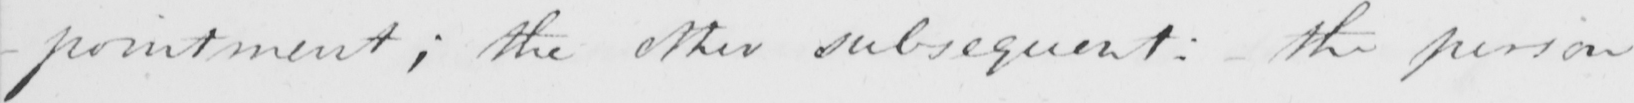What text is written in this handwritten line? -pointment ; the other subsequent :  the person 